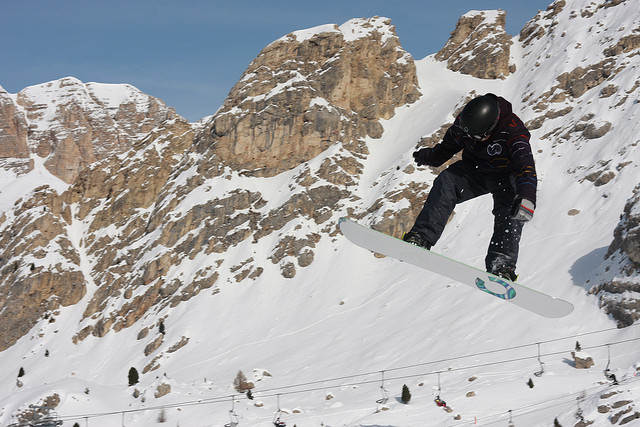Does the image suggest any cultural or regional associations? The rocky, snowy mountain terrain in the image could suggest associations with regions known for their alpine sports, such as the Alps in Europe, the Rockies in North America, or the Andes in South America. The presence of a ski lift indicates a developed winter sports area, likely frequented by tourists and locals alike. What kind of wildlife could inhabit such an environment? In such a high-altitude, snowy environment, wildlife might include species adapted to cold climates. Examples include mountain goats, which are skilled climbers navigating rocky terrains, snow leopards, and various bird species like the alpine chough. During different seasons, you might also spot smaller mammals like marmots and hares. If the snowboarder were to document their adventures, what kind of stories or photos would enhance their narrative? Stories could include thrilling moments of high jumps and aerial tricks, challenges faced on difficult terrains, and personal reflections on the sense of freedom and connection with nature. Photos might capture breathtaking landscapes, action shots of various tricks, close-ups of the snowboarder's expressions, and interactions with local wildlife or fellow adventurers. Documenting cultural experiences and local traditions encountered during travels would also enrich the narrative. Formulate a creative and wild scenario involving the snowboarder in a fantasy world. Imagine the snowboarder is navigating through an enchanted realm where each mountain peak is guarded by mythical creatures. To pass through the Rockies, they must soar over a dragon's lair, avoiding its icy breath. In the Alps, they team up with a group of snow sprites that guide them through shimmering, otherworldly snow tunnels. Finally, they arrive at the Crystal Peak, the highest mountain, where they must perform a legendary snowboarding trick to unlock the gateway to an ancient, hidden city of eternal winter, ruled by a benevolent ice queen. Along the journey, they gather magical artifacts and forge alliances with elven warriors, creating an epic tale of adventure, skill, and fantasy. 